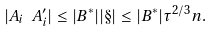Convert formula to latex. <formula><loc_0><loc_0><loc_500><loc_500>| A _ { i } \ A _ { i } ^ { \prime } | \leq | B ^ { * } | | \S | \leq | B ^ { * } | \tau ^ { 2 / 3 } n .</formula> 